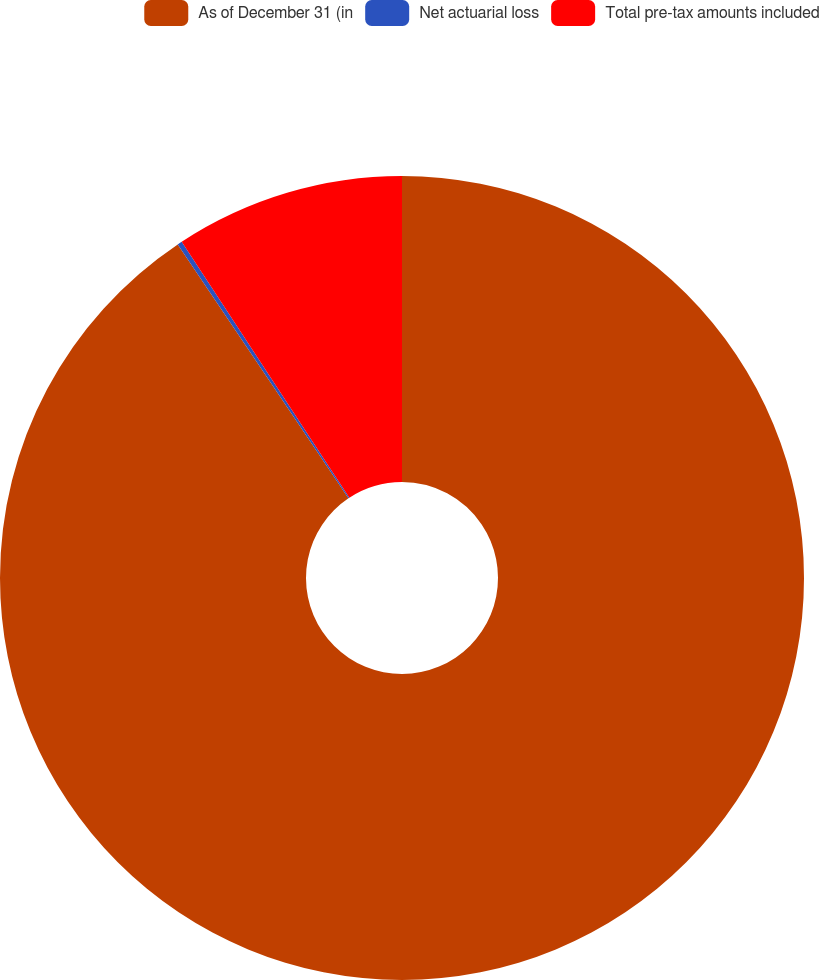Convert chart to OTSL. <chart><loc_0><loc_0><loc_500><loc_500><pie_chart><fcel>As of December 31 (in<fcel>Net actuarial loss<fcel>Total pre-tax amounts included<nl><fcel>90.58%<fcel>0.19%<fcel>9.23%<nl></chart> 